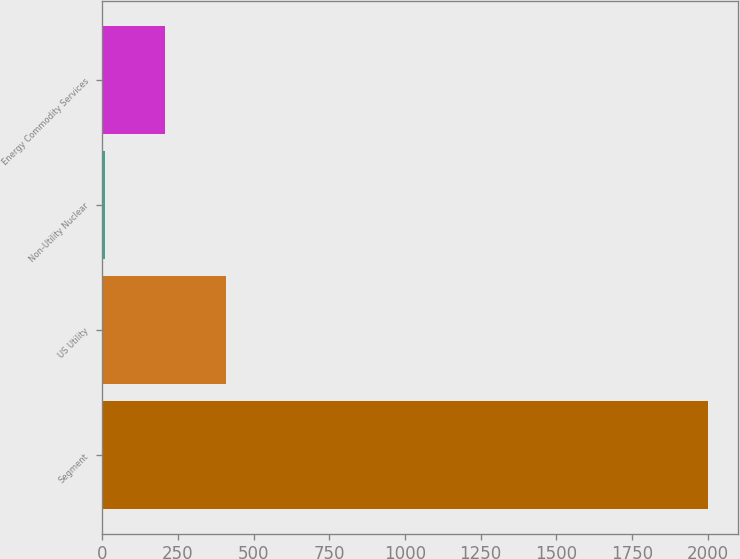Convert chart. <chart><loc_0><loc_0><loc_500><loc_500><bar_chart><fcel>Segment<fcel>US Utility<fcel>Non-Utility Nuclear<fcel>Energy Commodity Services<nl><fcel>2000<fcel>407.2<fcel>9<fcel>208.1<nl></chart> 